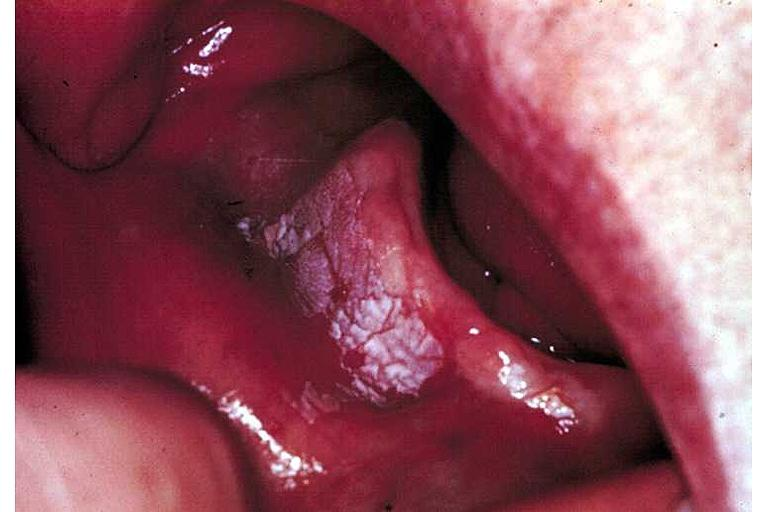does this image show leukoplakia?
Answer the question using a single word or phrase. Yes 